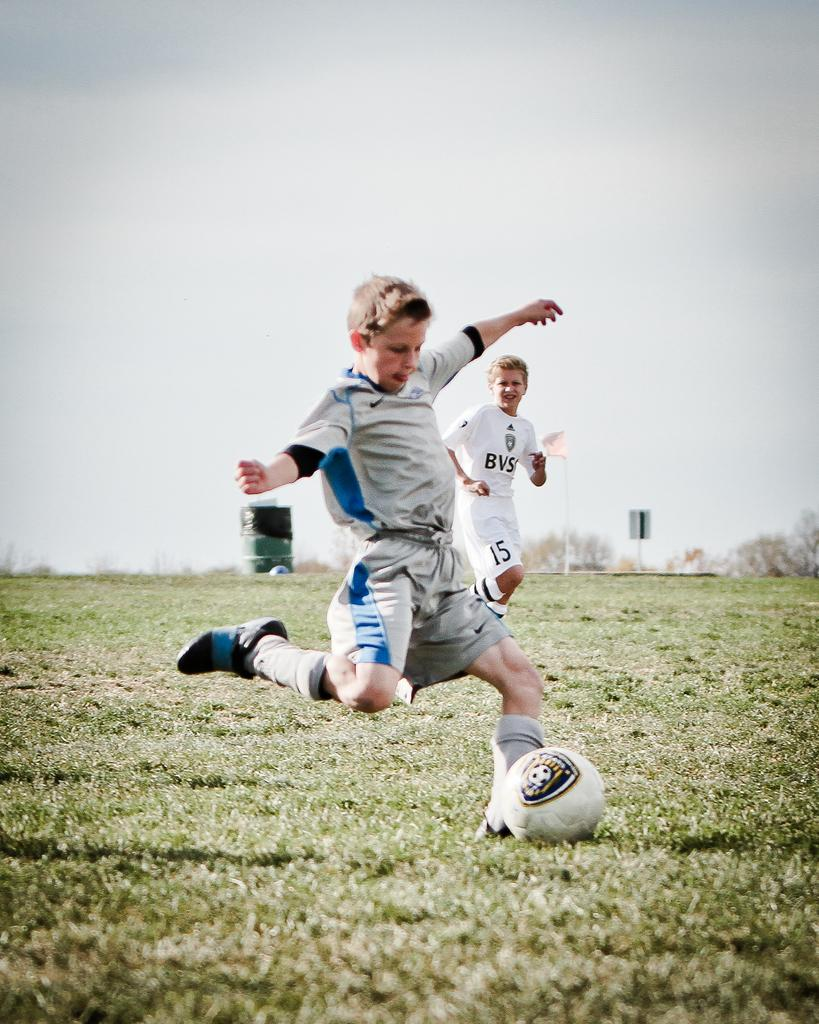How many boys are in the image? There are two boys in the center of the image. What activity are the boys engaged in? The boys are playing football. What type of surface are the boys playing on? There is grass at the bottom of the image. What can be seen in the background of the image? There are trees and the sky visible in the background of the image. What type of vegetable is being used as a border in the image? There is no vegetable being used as a border in the image. The image features boys playing football on grass, with trees and the sky in the background. 